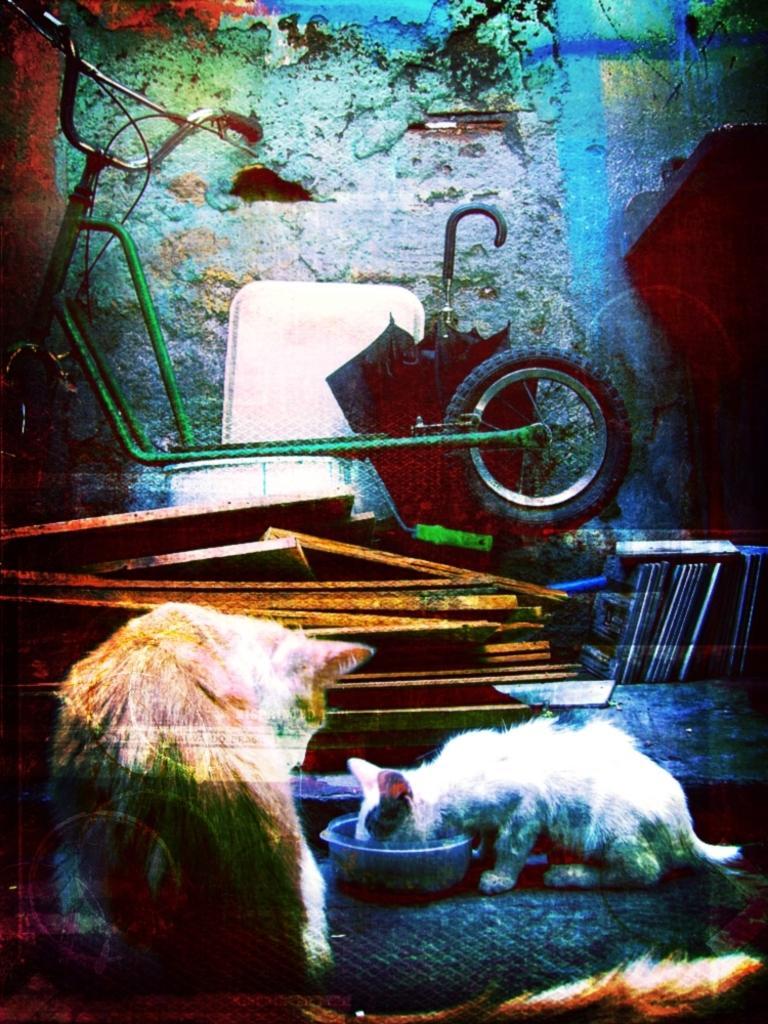Could you give a brief overview of what you see in this image? In this image there are two cats , umbrella, bowl, bicycle , wall and some other objects. 